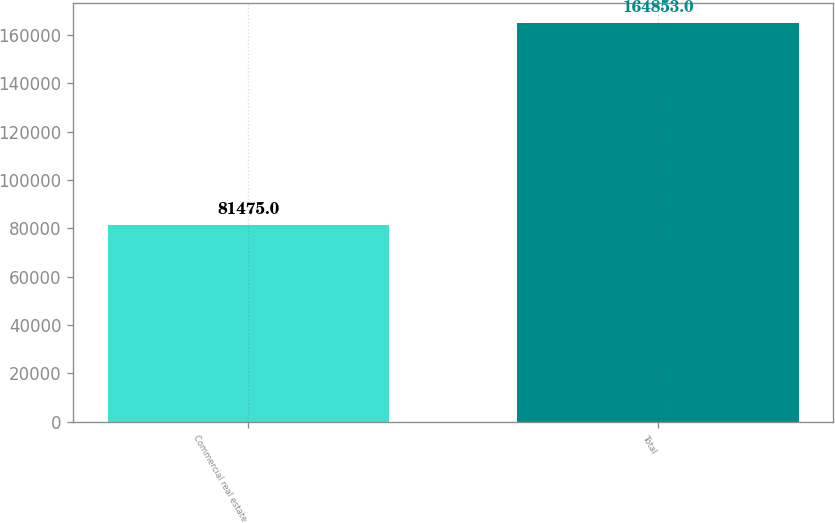<chart> <loc_0><loc_0><loc_500><loc_500><bar_chart><fcel>Commercial real estate<fcel>Total<nl><fcel>81475<fcel>164853<nl></chart> 